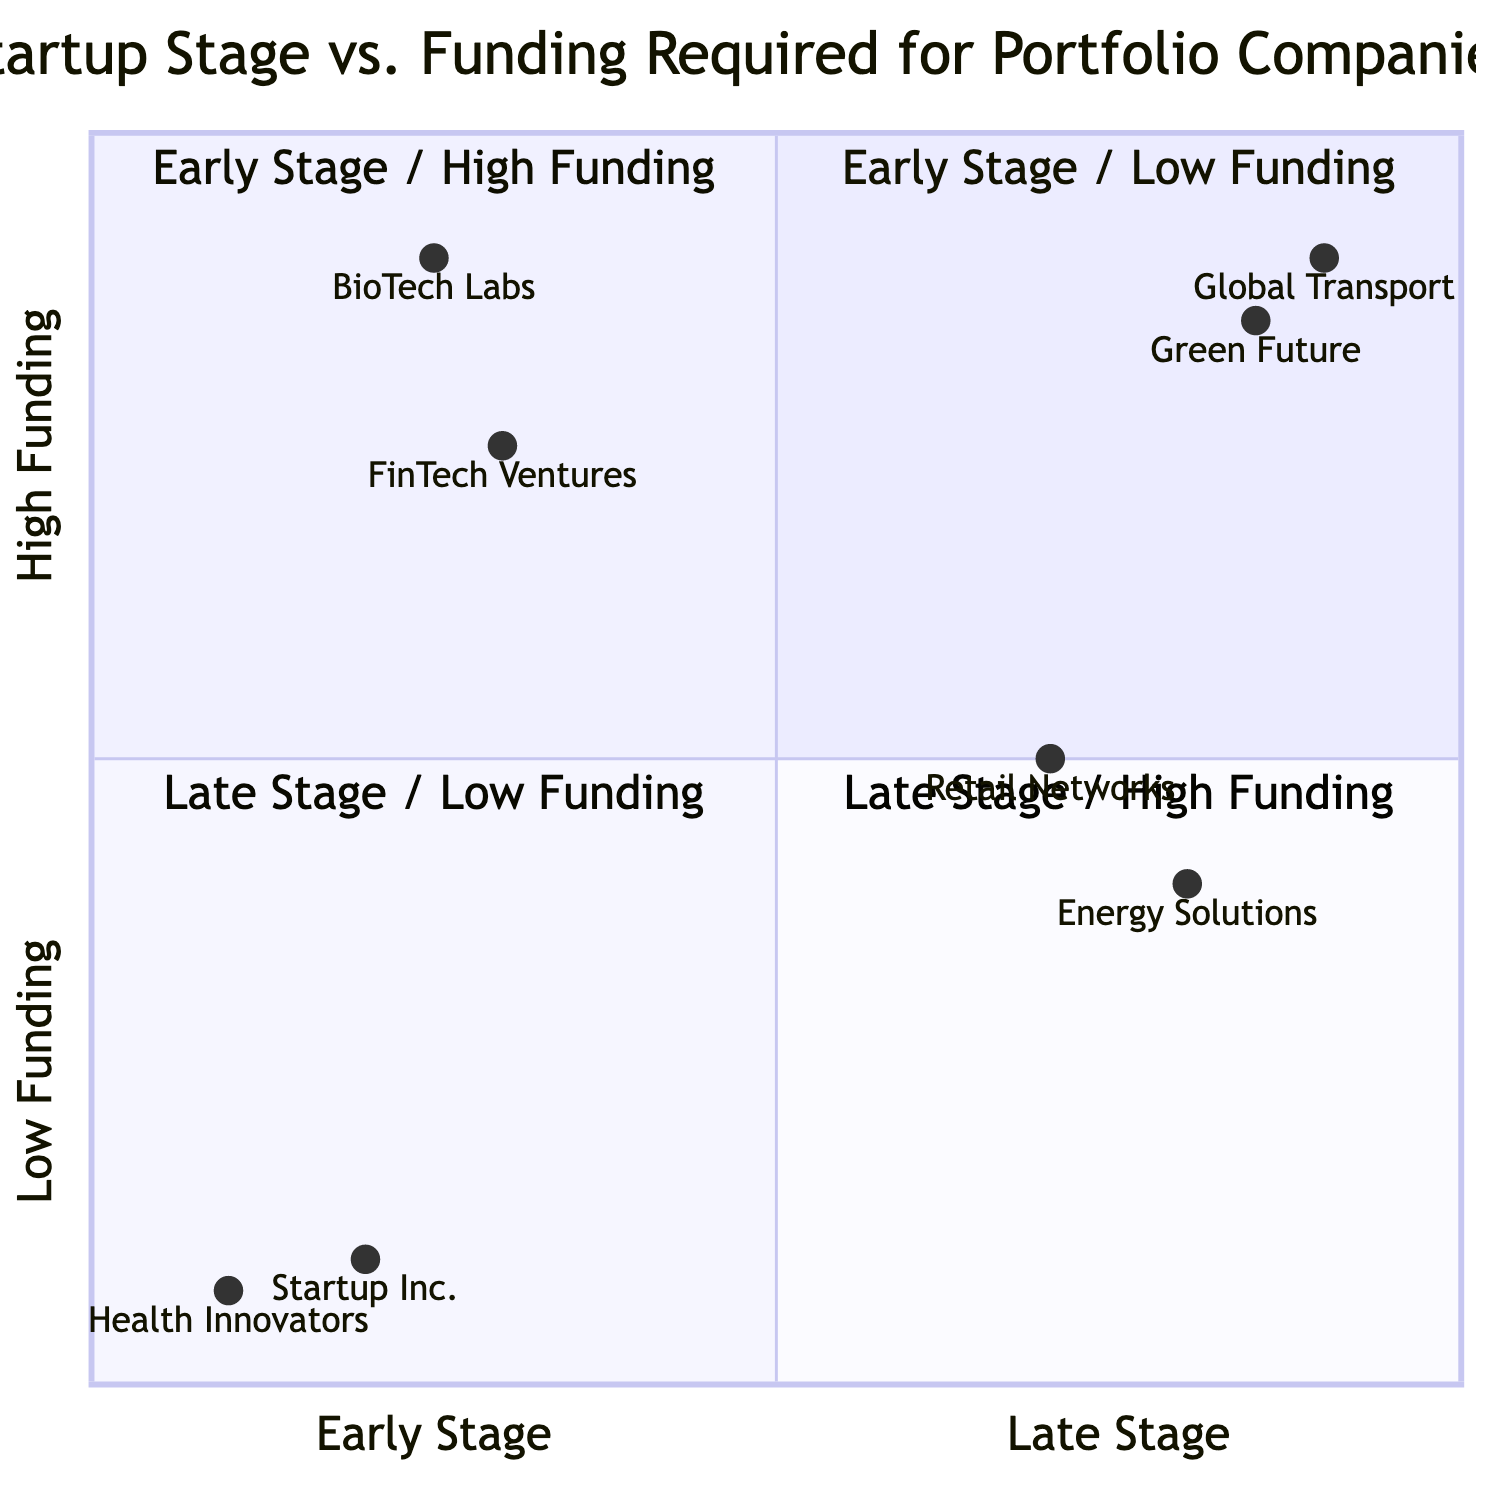What companies fall into the "Early Stage / Low Funding" quadrant? The "Early Stage / Low Funding" quadrant (Q1) contains two examples: "Startup Inc." and "Health Innovators".
Answer: Startup Inc., Health Innovators How much funding is required by "FinTech Ventures"? "FinTech Ventures" is located in the "Early Stage / High Funding" quadrant (Q2) and requires 15 million in funding.
Answer: 15 million Which quadrant contains "Global Transport"? "Global Transport" is located in the "Late Stage / High Funding" quadrant (Q4) as it is labeled clearly on the diagram.
Answer: Late Stage / High Funding Count the number of companies in the "Late Stage / Low Funding" quadrant. The "Late Stage / Low Funding" quadrant (Q3) has two examples: "Retail Networks" and "Energy Solutions", making a total of two companies.
Answer: 2 Which company is associated with the "Healthcare" sector in the "Early Stage / Low Funding" quadrant? In the "Early Stage / Low Funding" quadrant (Q1), "Health Innovators" is the company that is associated with the "Healthcare" sector.
Answer: Health Innovators What is the funding amount for "Green Future"? "Green Future" is found in the "Late Stage / High Funding" quadrant (Q4) and requires 45 million in funding.
Answer: 45 million Which quadrant has companies requiring less than 10 million in funding? The "Early Stage / Low Funding" quadrant (Q1) and the "Late Stage / Low Funding" quadrant (Q3) both contain companies that require less than 10 million in funding.
Answer: Early Stage / Low Funding, Late Stage / Low Funding What is the average funding required by companies in the "Late Stage / High Funding" quadrant? In the "Late Stage / High Funding" quadrant (Q4), "Global Transport" requires 50 million and "Green Future" requires 45 million. The average funding is calculated as (50 + 45) / 2 = 47.5 million.
Answer: 47.5 million 